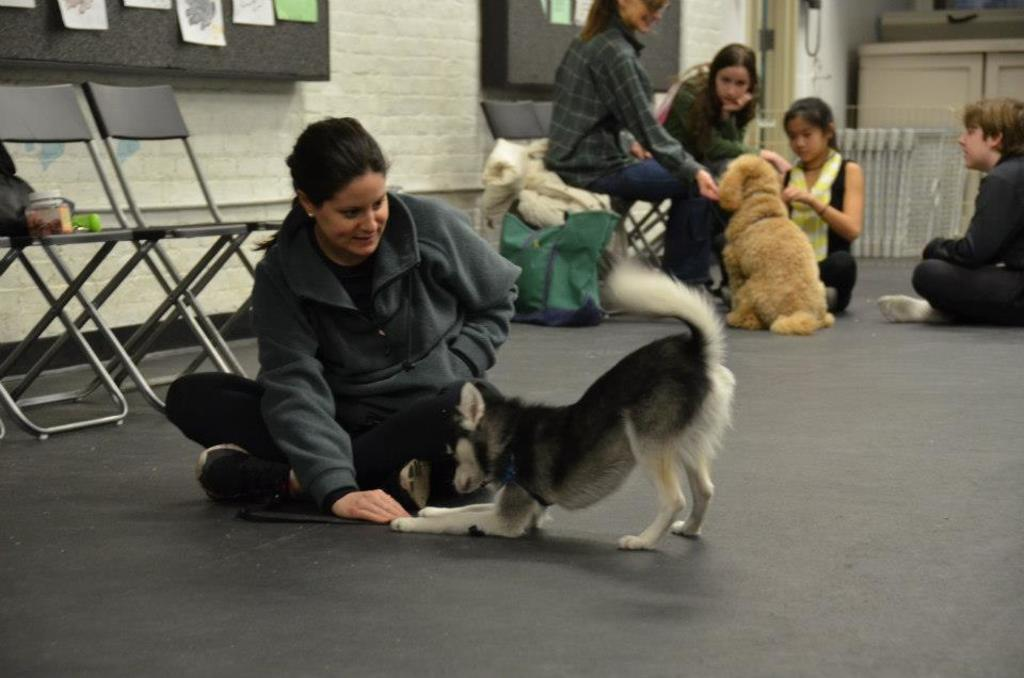Who or what is present in the image? There are people and two dogs in the image. What objects can be seen in the image besides the people and dogs? There is a bag and chairs in the image. What key is used to unlock the idea in the image? There is no key or idea present in the image; it features people, dogs, a bag, and chairs. 